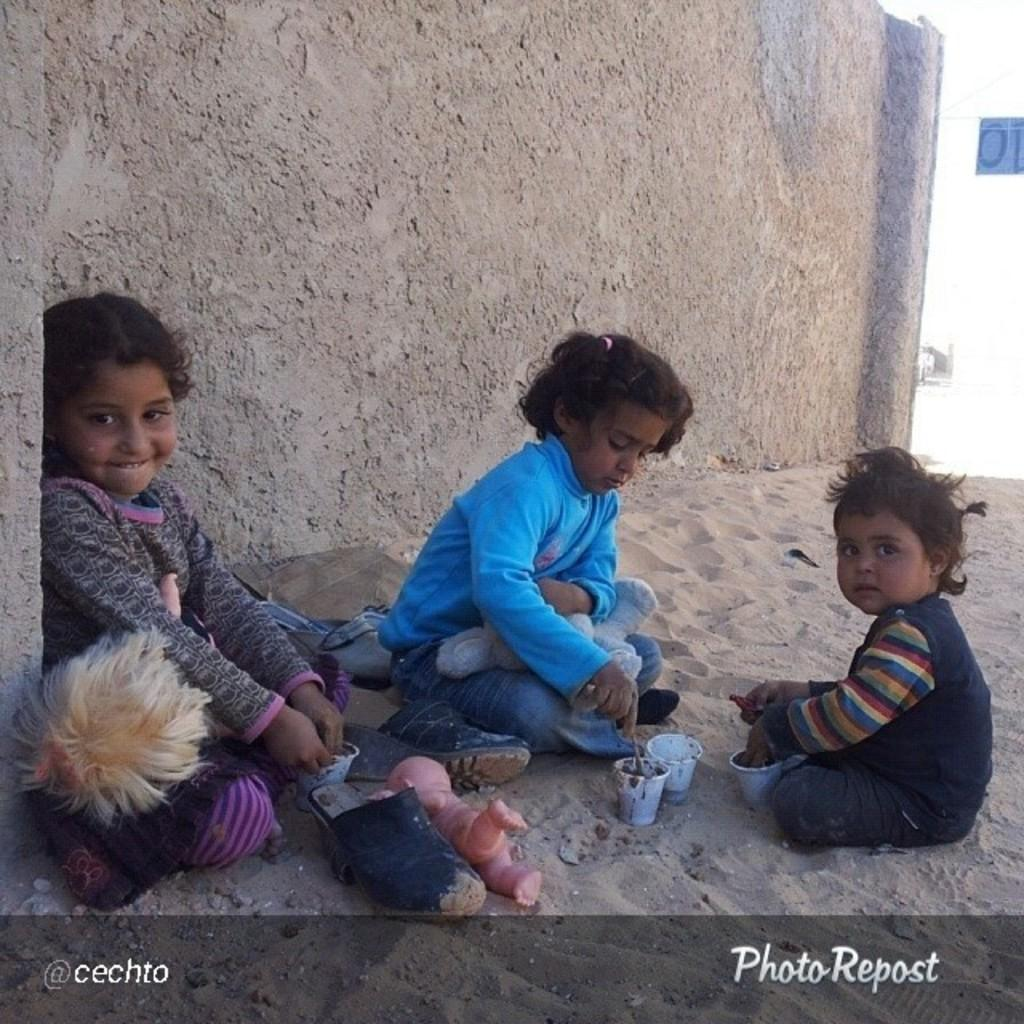How many kids are sitting on the sand in the image? There are three kids sitting on sand in the image. What can be seen in front of the kids? There are toys and cups in front of the kids. What is visible in the background of the image? There is a wall in the background of the image. What is written or displayed at the bottom of the image? There is text at the bottom of the image. What type of songs are the kids singing in the image? There is no indication in the image that the kids are singing songs, so it cannot be determined from the picture. 